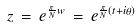Convert formula to latex. <formula><loc_0><loc_0><loc_500><loc_500>z \, = \, e ^ { \frac { \pi } { N } w } \, = \, e ^ { \frac { \pi } { N } ( t + i \theta ) }</formula> 